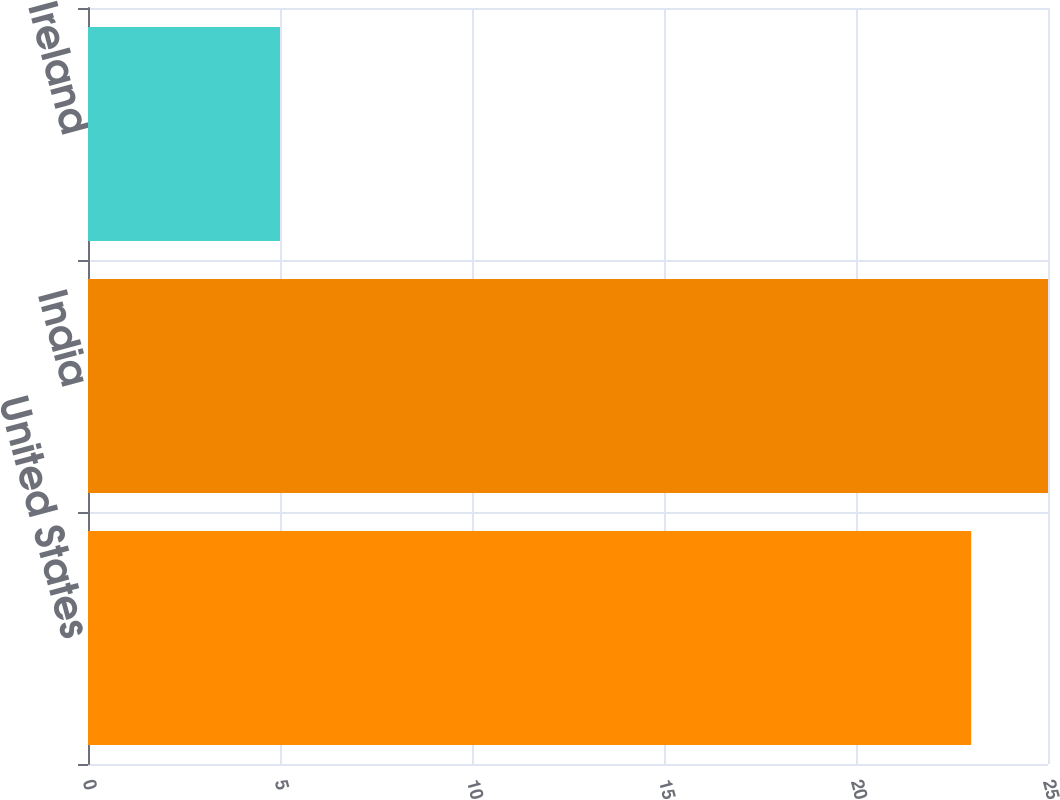Convert chart to OTSL. <chart><loc_0><loc_0><loc_500><loc_500><bar_chart><fcel>United States<fcel>India<fcel>Ireland<nl><fcel>23<fcel>25<fcel>5<nl></chart> 